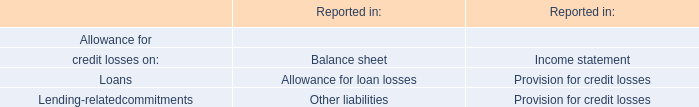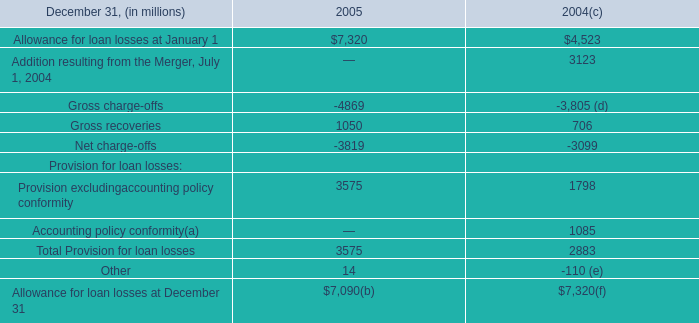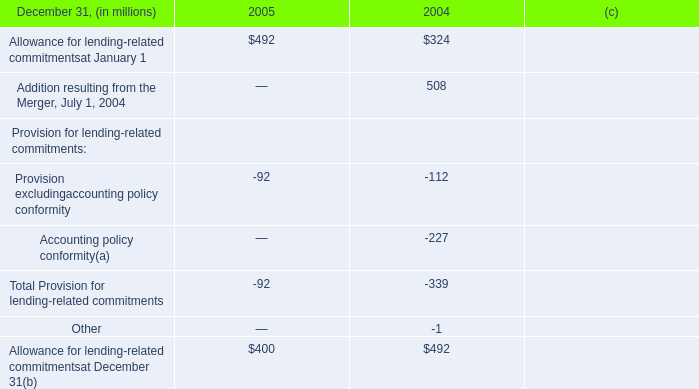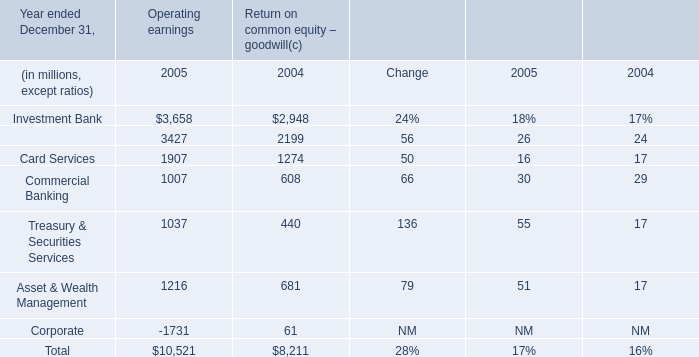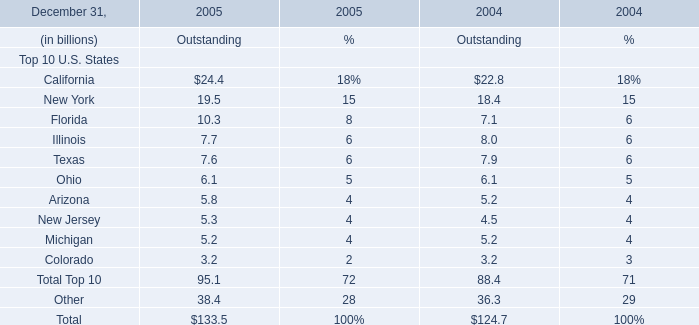What's the sum of the Ohio for Top 10 U.S. States for Outstanding in the years where Allowance for lending-related commitmentsat January 1 is greater than 0? (in billion) 
Computations: (6.1 + 6.1)
Answer: 12.2. 